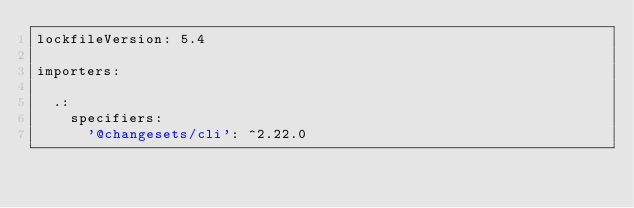Convert code to text. <code><loc_0><loc_0><loc_500><loc_500><_YAML_>lockfileVersion: 5.4

importers:

  .:
    specifiers:
      '@changesets/cli': ^2.22.0</code> 